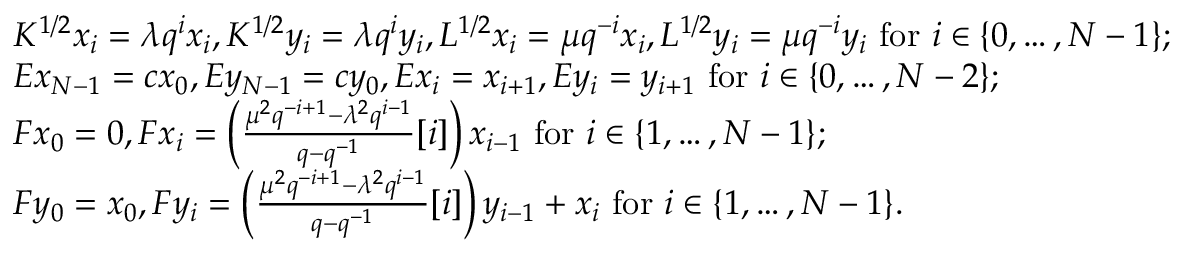<formula> <loc_0><loc_0><loc_500><loc_500>\begin{array} { r l } & { K ^ { 1 / 2 } x _ { i } = \lambda q ^ { i } x _ { i } , K ^ { 1 / 2 } y _ { i } = \lambda q ^ { i } y _ { i } , L ^ { 1 / 2 } x _ { i } = \mu q ^ { - i } x _ { i } , L ^ { 1 / 2 } y _ { i } = \mu q ^ { - i } y _ { i } f o r i \in \{ 0 , \dots , N - 1 \} ; } \\ & { E x _ { N - 1 } = c x _ { 0 } , E y _ { N - 1 } = c y _ { 0 } , E x _ { i } = x _ { i + 1 } , E y _ { i } = y _ { i + 1 } f o r i \in \{ 0 , \dots , N - 2 \} ; } \\ & { F x _ { 0 } = 0 , F x _ { i } = \left ( \frac { \mu ^ { 2 } q ^ { - i + 1 } - \lambda ^ { 2 } q ^ { i - 1 } } { q - q ^ { - 1 } } [ i ] \right ) x _ { i - 1 } f o r i \in \{ 1 , \dots , N - 1 \} ; } \\ & { F y _ { 0 } = x _ { 0 } , F y _ { i } = \left ( \frac { \mu ^ { 2 } q ^ { - i + 1 } - \lambda ^ { 2 } q ^ { i - 1 } } { q - q ^ { - 1 } } [ i ] \right ) y _ { i - 1 } + x _ { i } f o r i \in \{ 1 , \dots , N - 1 \} . } \end{array}</formula> 